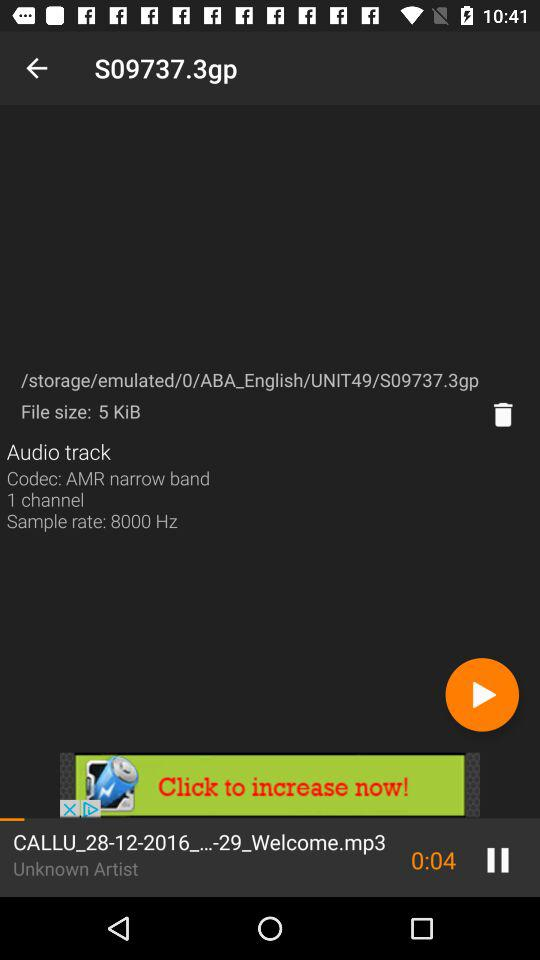What is the duration of the song? The duration of the song is 0:04. 